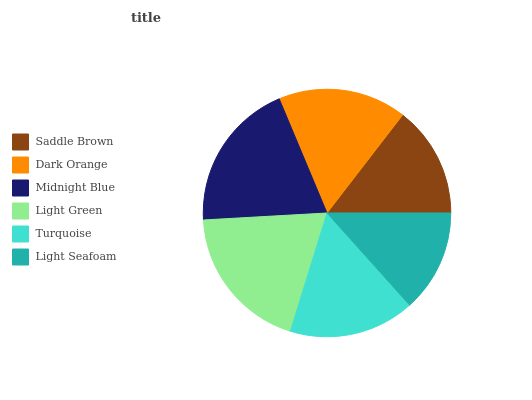Is Light Seafoam the minimum?
Answer yes or no. Yes. Is Midnight Blue the maximum?
Answer yes or no. Yes. Is Dark Orange the minimum?
Answer yes or no. No. Is Dark Orange the maximum?
Answer yes or no. No. Is Dark Orange greater than Saddle Brown?
Answer yes or no. Yes. Is Saddle Brown less than Dark Orange?
Answer yes or no. Yes. Is Saddle Brown greater than Dark Orange?
Answer yes or no. No. Is Dark Orange less than Saddle Brown?
Answer yes or no. No. Is Dark Orange the high median?
Answer yes or no. Yes. Is Turquoise the low median?
Answer yes or no. Yes. Is Turquoise the high median?
Answer yes or no. No. Is Dark Orange the low median?
Answer yes or no. No. 